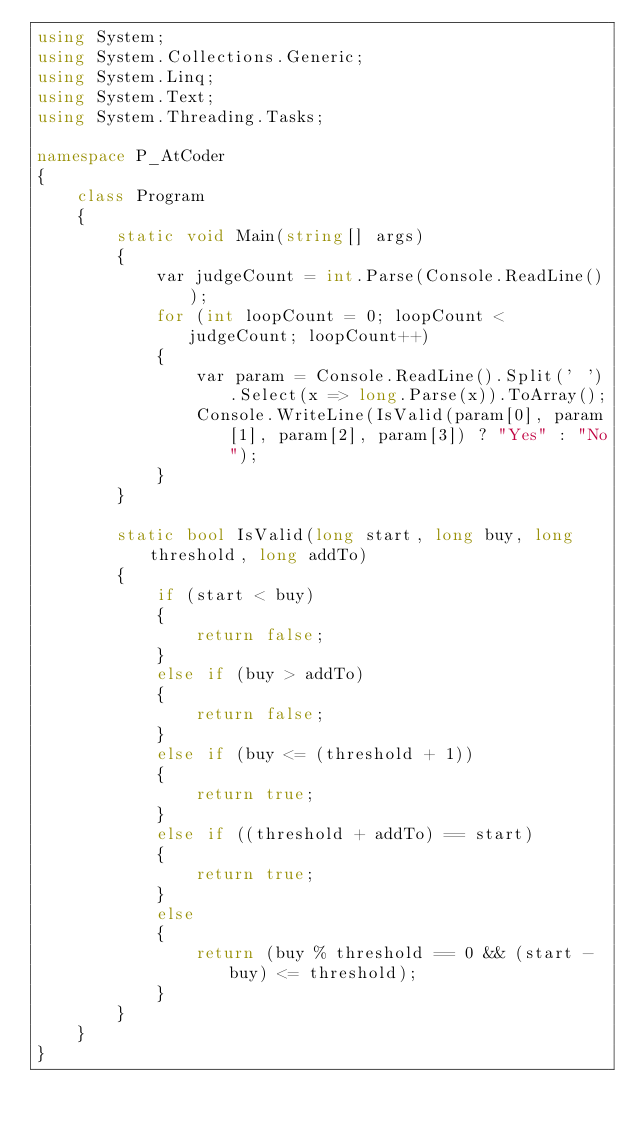Convert code to text. <code><loc_0><loc_0><loc_500><loc_500><_C#_>using System;
using System.Collections.Generic;
using System.Linq;
using System.Text;
using System.Threading.Tasks;

namespace P_AtCoder
{
    class Program
    {
        static void Main(string[] args)
        {
            var judgeCount = int.Parse(Console.ReadLine());
            for (int loopCount = 0; loopCount < judgeCount; loopCount++)
            {
                var param = Console.ReadLine().Split(' ').Select(x => long.Parse(x)).ToArray();
                Console.WriteLine(IsValid(param[0], param[1], param[2], param[3]) ? "Yes" : "No");
            }
        }

        static bool IsValid(long start, long buy, long threshold, long addTo)
        {
            if (start < buy)
            {
                return false;
            }
            else if (buy > addTo)
            {
                return false;
            }
            else if (buy <= (threshold + 1))
            {
                return true;
            }
            else if ((threshold + addTo) == start)
            {
                return true;
            }
            else
            {
                return (buy % threshold == 0 && (start - buy) <= threshold);
            }
        }
    }
}
</code> 